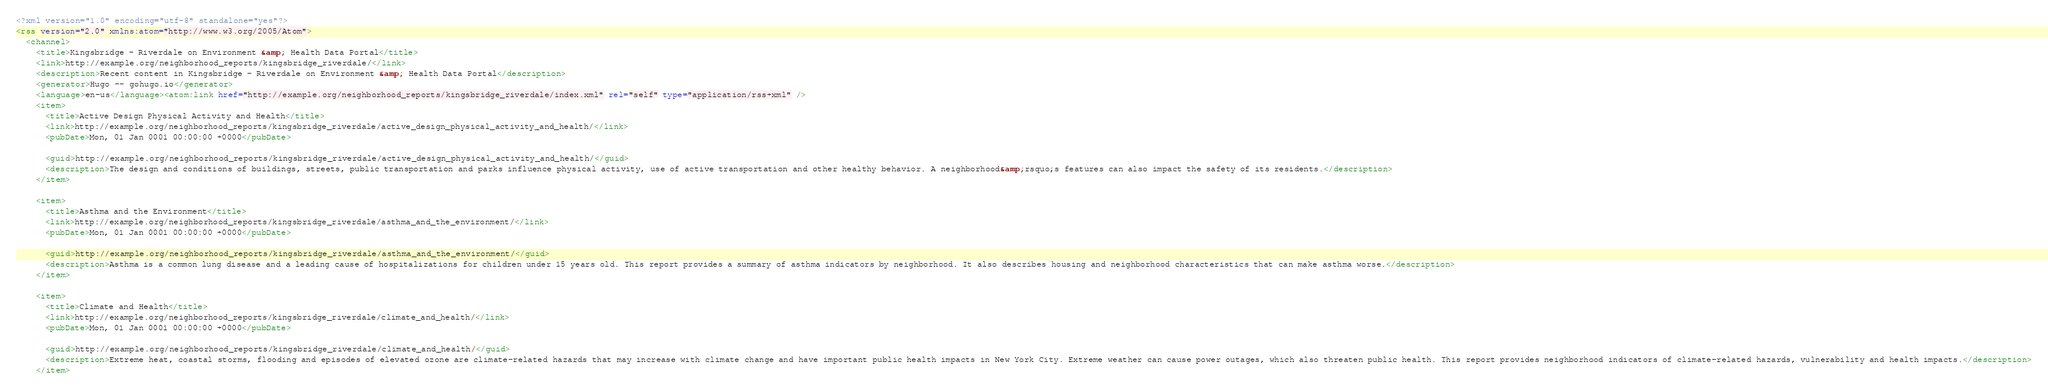<code> <loc_0><loc_0><loc_500><loc_500><_XML_><?xml version="1.0" encoding="utf-8" standalone="yes"?>
<rss version="2.0" xmlns:atom="http://www.w3.org/2005/Atom">
  <channel>
    <title>Kingsbridge - Riverdale on Environment &amp; Health Data Portal</title>
    <link>http://example.org/neighborhood_reports/kingsbridge_riverdale/</link>
    <description>Recent content in Kingsbridge - Riverdale on Environment &amp; Health Data Portal</description>
    <generator>Hugo -- gohugo.io</generator>
    <language>en-us</language><atom:link href="http://example.org/neighborhood_reports/kingsbridge_riverdale/index.xml" rel="self" type="application/rss+xml" />
    <item>
      <title>Active Design Physical Activity and Health</title>
      <link>http://example.org/neighborhood_reports/kingsbridge_riverdale/active_design_physical_activity_and_health/</link>
      <pubDate>Mon, 01 Jan 0001 00:00:00 +0000</pubDate>
      
      <guid>http://example.org/neighborhood_reports/kingsbridge_riverdale/active_design_physical_activity_and_health/</guid>
      <description>The design and conditions of buildings, streets, public transportation and parks influence physical activity, use of active transportation and other healthy behavior. A neighborhood&amp;rsquo;s features can also impact the safety of its residents.</description>
    </item>
    
    <item>
      <title>Asthma and the Environment</title>
      <link>http://example.org/neighborhood_reports/kingsbridge_riverdale/asthma_and_the_environment/</link>
      <pubDate>Mon, 01 Jan 0001 00:00:00 +0000</pubDate>
      
      <guid>http://example.org/neighborhood_reports/kingsbridge_riverdale/asthma_and_the_environment/</guid>
      <description>Asthma is a common lung disease and a leading cause of hospitalizations for children under 15 years old. This report provides a summary of asthma indicators by neighborhood. It also describes housing and neighborhood characteristics that can make asthma worse.</description>
    </item>
    
    <item>
      <title>Climate and Health</title>
      <link>http://example.org/neighborhood_reports/kingsbridge_riverdale/climate_and_health/</link>
      <pubDate>Mon, 01 Jan 0001 00:00:00 +0000</pubDate>
      
      <guid>http://example.org/neighborhood_reports/kingsbridge_riverdale/climate_and_health/</guid>
      <description>Extreme heat, coastal storms, flooding and episodes of elevated ozone are climate-related hazards that may increase with climate change and have important public health impacts in New York City. Extreme weather can cause power outages, which also threaten public health. This report provides neighborhood indicators of climate-related hazards, vulnerability and health impacts.</description>
    </item></code> 